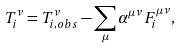Convert formula to latex. <formula><loc_0><loc_0><loc_500><loc_500>T ^ { \nu } _ { i } = T _ { i , o b s } ^ { \nu } - \sum _ { \mu } \alpha ^ { \mu \nu } F _ { i } ^ { \mu \nu } ,</formula> 